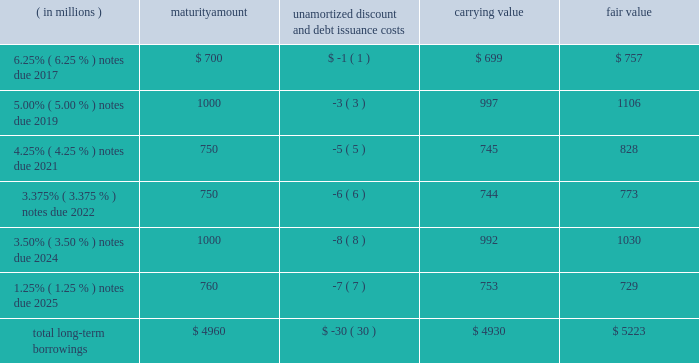12 .
Borrowings short-term borrowings 2015 revolving credit facility .
In march 2011 , the company entered into a five-year $ 3.5 billion unsecured revolving credit facility , which was amended in 2014 , 2013 and 2012 .
In april 2015 , the company 2019s credit facility was further amended to extend the maturity date to march 2020 and to increase the amount of the aggregate commitment to $ 4.0 billion ( the 201c2015 credit facility 201d ) .
The 2015 credit facility permits the company to request up to an additional $ 1.0 billion of borrowing capacity , subject to lender credit approval , increasing the overall size of the 2015 credit facility to an aggregate principal amount not to exceed $ 5.0 billion .
Interest on borrowings outstanding accrues at a rate based on the applicable london interbank offered rate plus a spread .
The 2015 credit facility requires the company not to exceed a maximum leverage ratio ( ratio of net debt to earnings before interest , taxes , depreciation and amortization , where net debt equals total debt less unrestricted cash ) of 3 to 1 , which was satisfied with a ratio of less than 1 to 1 at december 31 , 2015 .
The 2015 credit facility provides back-up liquidity to fund ongoing working capital for general corporate purposes and various investment opportunities .
At december 31 , 2015 , the company had no amount outstanding under the 2015 credit facility .
Commercial paper program .
On october 14 , 2009 , blackrock established a commercial paper program ( the 201ccp program 201d ) under which the company could issue unsecured commercial paper notes ( the 201ccp notes 201d ) on a private placement basis up to a maximum aggregate amount outstanding at any time of $ 4.0 billion as amended in april 2015 .
The cp program is currently supported by the 2015 credit facility .
At december 31 , 2015 , blackrock had no cp notes outstanding .
Long-term borrowings the carrying value and fair value of long-term borrowings estimated using market prices and foreign exchange rates at december 31 , 2015 included the following : ( in millions ) maturity amount unamortized discount and debt issuance costs carrying value fair value .
Long-term borrowings at december 31 , 2014 had a carrying value of $ 4.922 billion and a fair value of $ 5.309 billion determined using market prices at the end of december 2025 notes .
In may 2015 , the company issued 20ac700 million of 1.25% ( 1.25 % ) senior unsecured notes maturing on may 6 , 2025 ( the 201c2025 notes 201d ) .
The notes are listed on the new york stock exchange .
The net proceeds of the 2025 notes were used for general corporate purposes , including refinancing of outstanding indebtedness .
Interest of approximately $ 10 million per year based on current exchange rates is payable annually on may 6 of each year .
The 2025 notes may be redeemed in whole or in part prior to maturity at any time at the option of the company at a 201cmake-whole 201d redemption price .
The unamortized discount and debt issuance costs are being amortized over the remaining term of the 2025 notes .
Upon conversion to u.s .
Dollars the company designated the 20ac700 million debt offering as a net investment hedge to offset its currency exposure relating to its net investment in certain euro functional currency operations .
A gain of $ 19 million , net of tax , was recognized in other comprehensive income for 2015 .
No hedge ineffectiveness was recognized during 2015 .
2024 notes .
In march 2014 , the company issued $ 1.0 billion in aggregate principal amount of 3.50% ( 3.50 % ) senior unsecured and unsubordinated notes maturing on march 18 , 2024 ( the 201c2024 notes 201d ) .
The net proceeds of the 2024 notes were used to refinance certain indebtedness which matured in the fourth quarter of 2014 .
Interest is payable semi-annually in arrears on march 18 and september 18 of each year , or approximately $ 35 million per year .
The 2024 notes may be redeemed prior to maturity at any time in whole or in part at the option of the company at a 201cmake-whole 201d redemption price .
The unamortized discount and debt issuance costs are being amortized over the remaining term of the 2024 notes .
2022 notes .
In may 2012 , the company issued $ 1.5 billion in aggregate principal amount of unsecured unsubordinated obligations .
These notes were issued as two separate series of senior debt securities , including $ 750 million of 1.375% ( 1.375 % ) notes , which were repaid in june 2015 at maturity , and $ 750 million of 3.375% ( 3.375 % ) notes maturing in june 2022 ( the 201c2022 notes 201d ) .
Net proceeds were used to fund the repurchase of blackrock 2019s common stock and series b preferred from barclays and affiliates and for general corporate purposes .
Interest on the 2022 notes of approximately $ 25 million per year , respectively , is payable semi-annually on june 1 and december 1 of each year , which commenced december 1 , 2012 .
The 2022 notes may be redeemed prior to maturity at any time in whole or in part at the option of the company at a 201cmake-whole 201d redemption price .
The 201cmake-whole 201d redemption price represents a price , subject to the specific terms of the 2022 notes and related indenture , that is the greater of ( a ) par value and ( b ) the present value of future payments that will not be paid because of an early redemption , which is discounted at a fixed spread over a .
What portion of total long-term borrowings is due in the next 36 months as of december 31 , 2015? 
Computations: (700 + 4960)
Answer: 5660.0. 